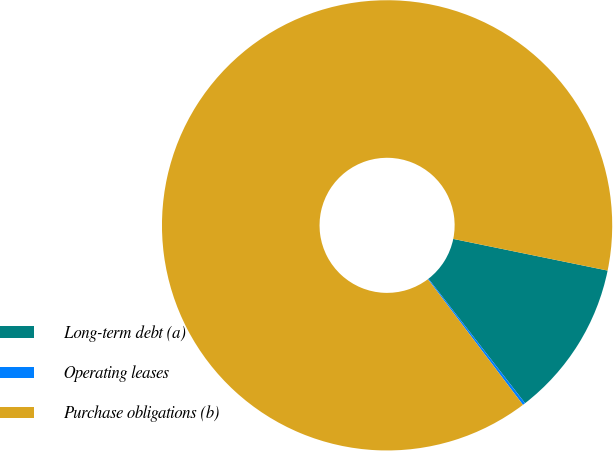<chart> <loc_0><loc_0><loc_500><loc_500><pie_chart><fcel>Long-term debt (a)<fcel>Operating leases<fcel>Purchase obligations (b)<nl><fcel>11.28%<fcel>0.19%<fcel>88.53%<nl></chart> 